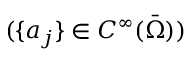<formula> <loc_0><loc_0><loc_500><loc_500>( \{ a _ { j } \} \in C ^ { \infty } ( \ B a r { \Omega } ) )</formula> 